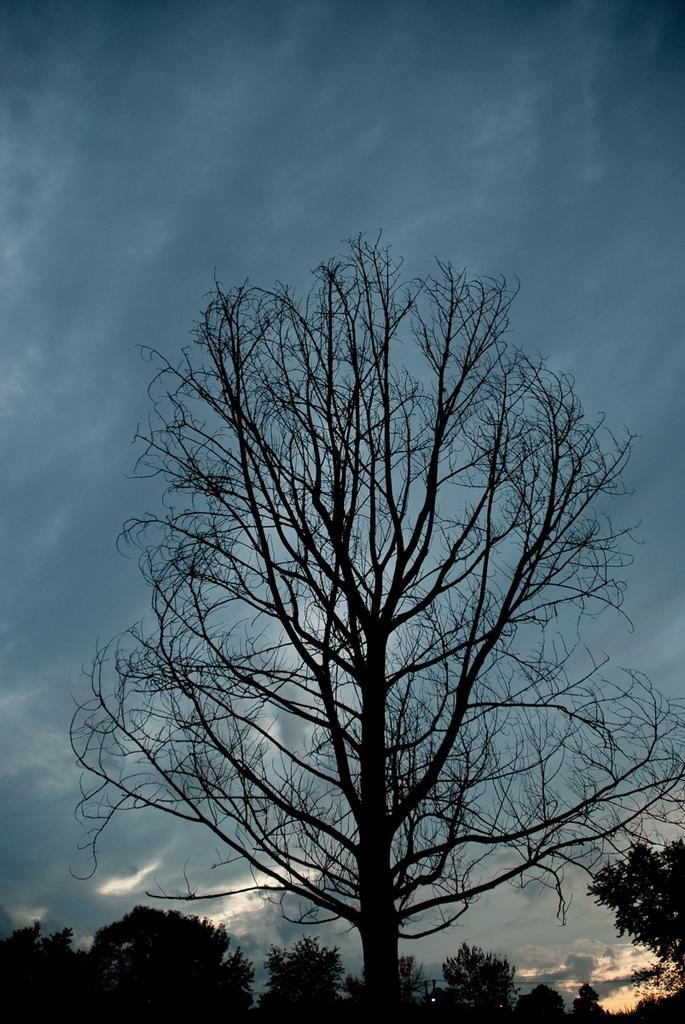Describe this image in one or two sentences. In this image I can see a dark picture in which I can see few trees which are black in color. In the background I can see the sky. 